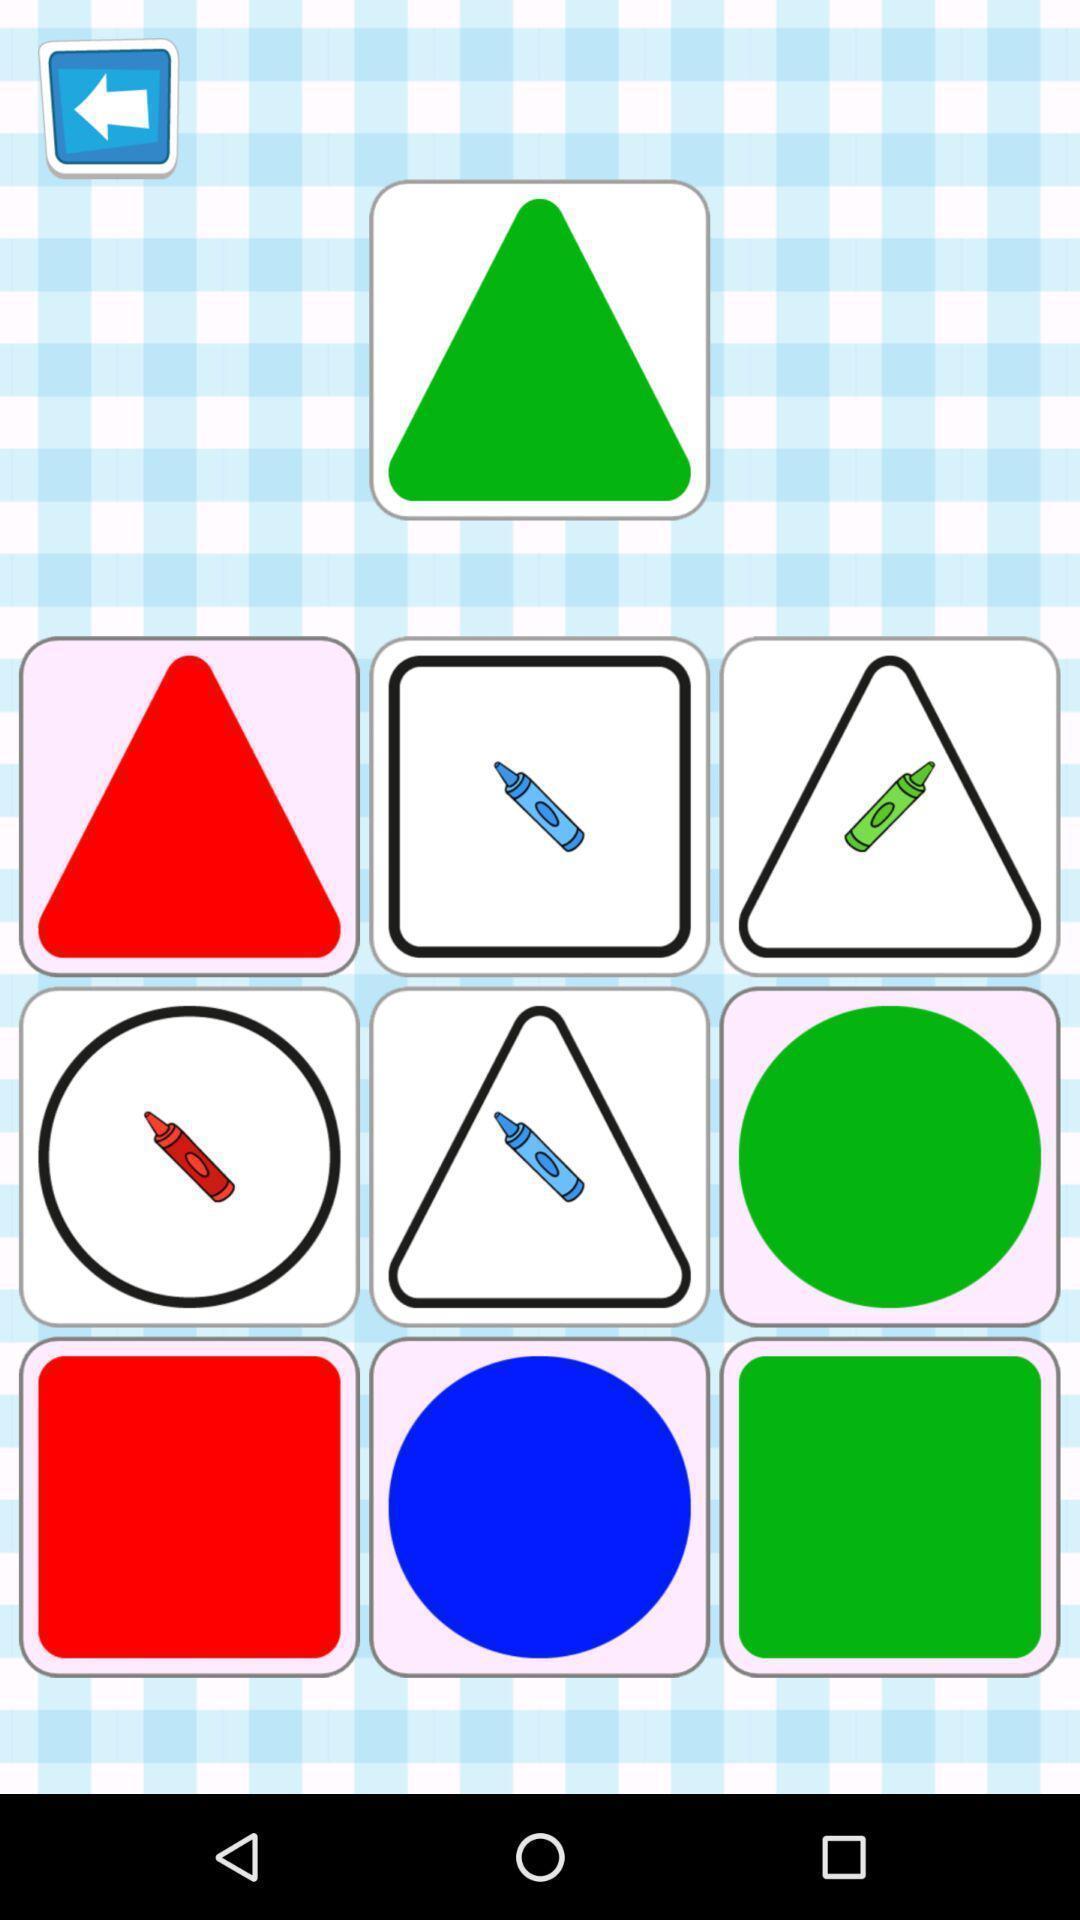Describe the visual elements of this screenshot. Screen showing different colors and shapes. 